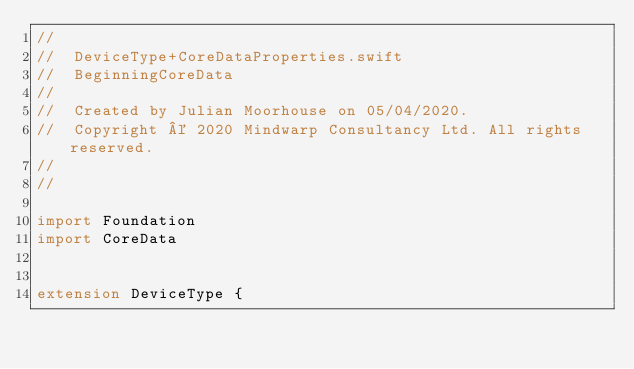Convert code to text. <code><loc_0><loc_0><loc_500><loc_500><_Swift_>//
//  DeviceType+CoreDataProperties.swift
//  BeginningCoreData
//
//  Created by Julian Moorhouse on 05/04/2020.
//  Copyright © 2020 Mindwarp Consultancy Ltd. All rights reserved.
//
//

import Foundation
import CoreData


extension DeviceType {
</code> 